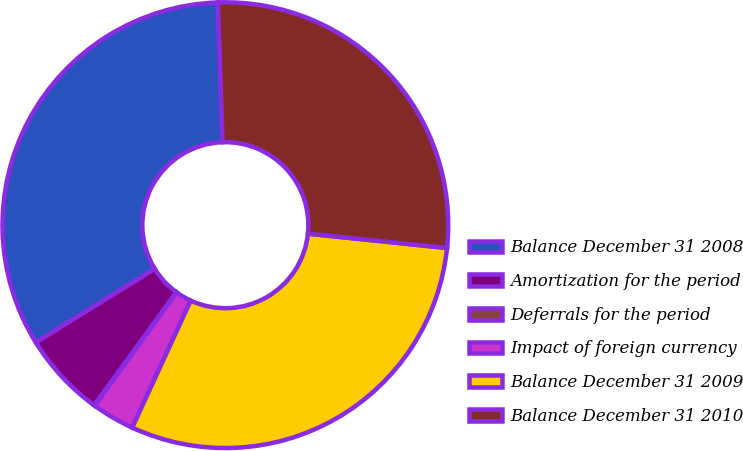Convert chart to OTSL. <chart><loc_0><loc_0><loc_500><loc_500><pie_chart><fcel>Balance December 31 2008<fcel>Amortization for the period<fcel>Deferrals for the period<fcel>Impact of foreign currency<fcel>Balance December 31 2009<fcel>Balance December 31 2010<nl><fcel>33.29%<fcel>6.17%<fcel>0.04%<fcel>3.11%<fcel>30.23%<fcel>27.17%<nl></chart> 